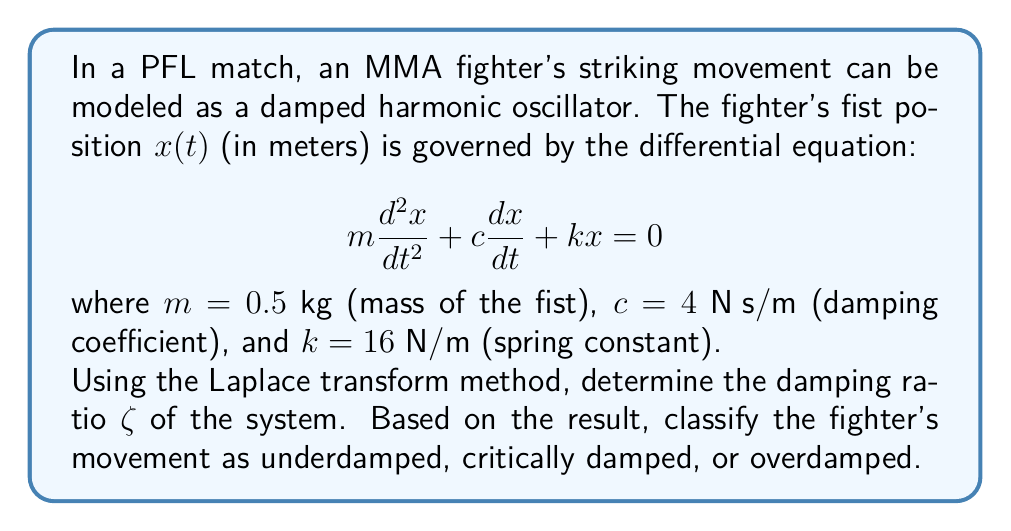Help me with this question. Let's solve this step-by-step using the Laplace transform method:

1) First, we take the Laplace transform of the given differential equation:
   $$\mathcal{L}\{m\frac{d^2x}{dt^2} + c\frac{dx}{dt} + kx = 0\}$$

2) Using the properties of Laplace transforms:
   $$m[s^2X(s) - sx(0) - x'(0)] + c[sX(s) - x(0)] + kX(s) = 0$$

3) Assuming initial conditions $x(0) = 0$ and $x'(0) = 0$:
   $$ms^2X(s) + csX(s) + kX(s) = 0$$

4) Factoring out $X(s)$:
   $$X(s)(ms^2 + cs + k) = 0$$

5) The characteristic equation is:
   $$ms^2 + cs + k = 0$$

6) Substituting the given values:
   $$0.5s^2 + 4s + 16 = 0$$

7) The general form of a second-order system is:
   $$s^2 + 2\zeta\omega_n s + \omega_n^2 = 0$$

   where $\zeta$ is the damping ratio and $\omega_n$ is the natural frequency.

8) Comparing our equation to the general form:
   $$s^2 + 8s + 32 = 0$$

9) We can identify:
   $$\omega_n = \sqrt{32} = 4\sqrt{2}$$
   $$2\zeta\omega_n = 8$$

10) Solving for $\zeta$:
    $$\zeta = \frac{8}{2\omega_n} = \frac{8}{2(4\sqrt{2})} = \frac{\sqrt{2}}{2} \approx 0.707$$

11) Since $0 < \zeta < 1$, the system is underdamped.
Answer: $\zeta = \frac{\sqrt{2}}{2}$; underdamped 